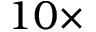Convert formula to latex. <formula><loc_0><loc_0><loc_500><loc_500>1 0 \times</formula> 